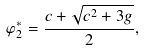<formula> <loc_0><loc_0><loc_500><loc_500>\varphi _ { 2 } ^ { * } = \frac { c + \sqrt { c ^ { 2 } + 3 g } } { 2 } ,</formula> 